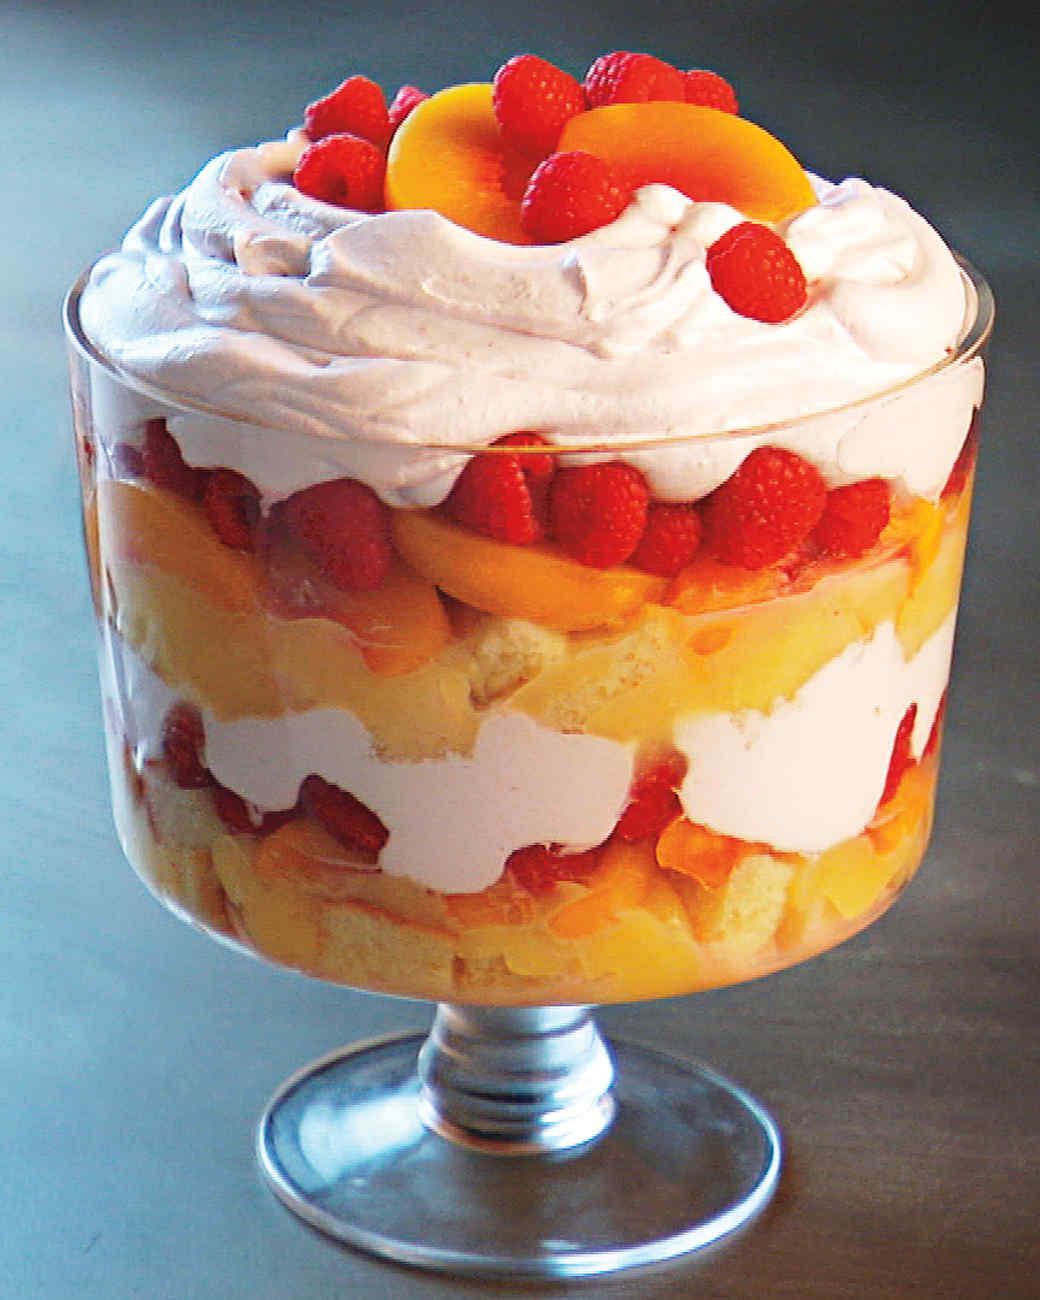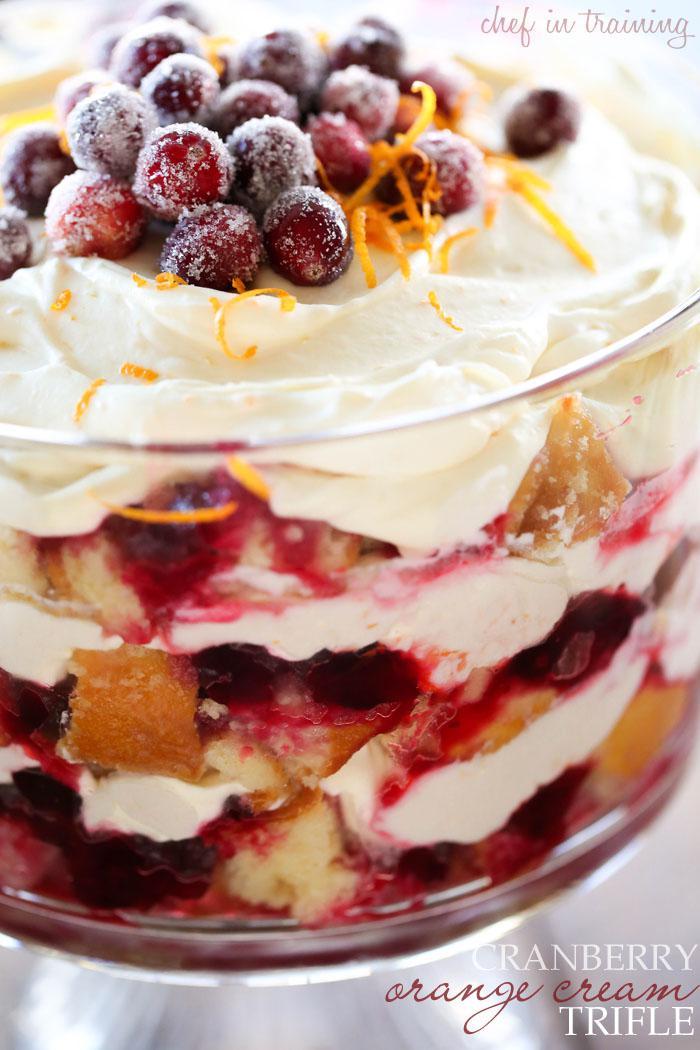The first image is the image on the left, the second image is the image on the right. For the images shown, is this caption "at least one trifle dessert has fruit on top" true? Answer yes or no. Yes. The first image is the image on the left, the second image is the image on the right. Given the left and right images, does the statement "A round bowl with a lip are features in both images." hold true? Answer yes or no. No. 